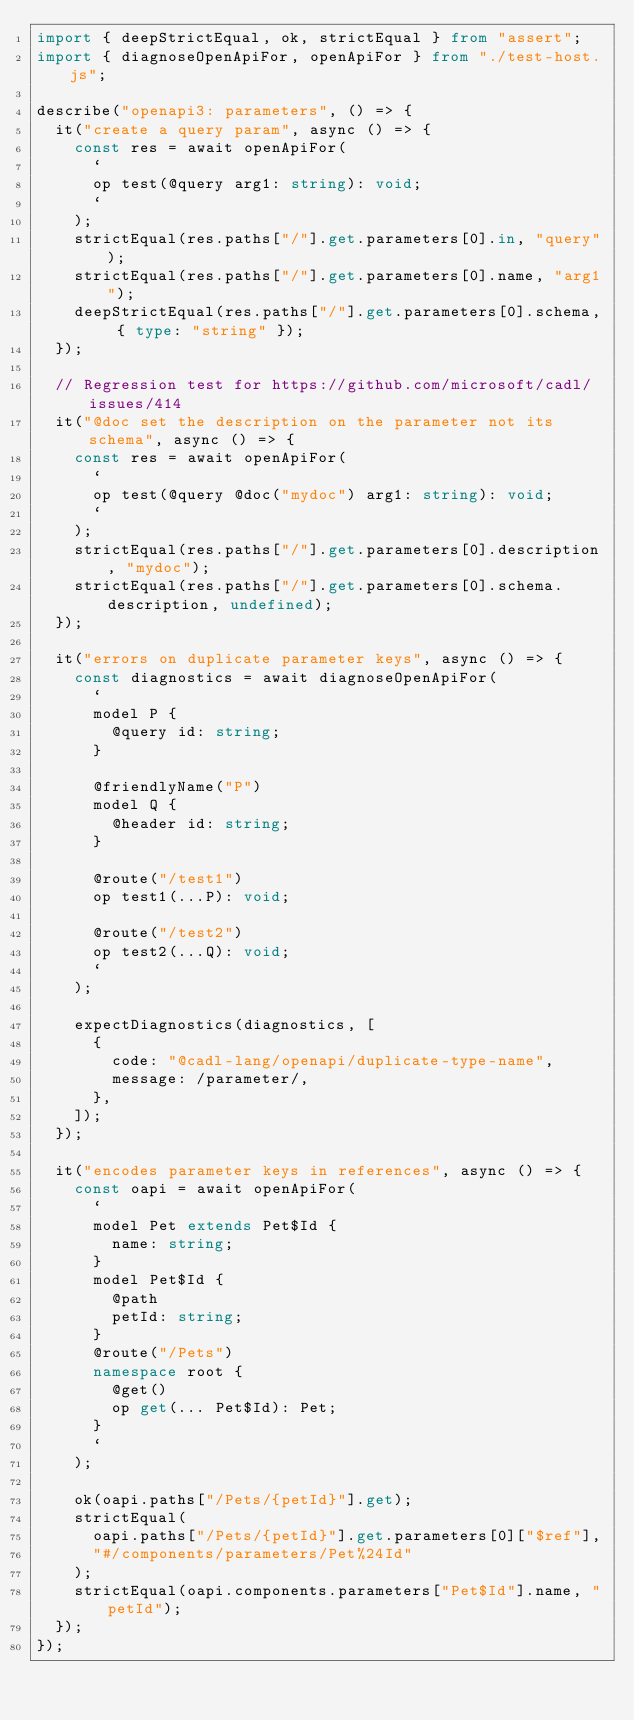<code> <loc_0><loc_0><loc_500><loc_500><_TypeScript_>import { deepStrictEqual, ok, strictEqual } from "assert";
import { diagnoseOpenApiFor, openApiFor } from "./test-host.js";

describe("openapi3: parameters", () => {
  it("create a query param", async () => {
    const res = await openApiFor(
      `
      op test(@query arg1: string): void;
      `
    );
    strictEqual(res.paths["/"].get.parameters[0].in, "query");
    strictEqual(res.paths["/"].get.parameters[0].name, "arg1");
    deepStrictEqual(res.paths["/"].get.parameters[0].schema, { type: "string" });
  });

  // Regression test for https://github.com/microsoft/cadl/issues/414
  it("@doc set the description on the parameter not its schema", async () => {
    const res = await openApiFor(
      `
      op test(@query @doc("mydoc") arg1: string): void;
      `
    );
    strictEqual(res.paths["/"].get.parameters[0].description, "mydoc");
    strictEqual(res.paths["/"].get.parameters[0].schema.description, undefined);
  });

  it("errors on duplicate parameter keys", async () => {
    const diagnostics = await diagnoseOpenApiFor(
      `
      model P {
        @query id: string;
      }

      @friendlyName("P")
      model Q {
        @header id: string;
      }

      @route("/test1")
      op test1(...P): void;

      @route("/test2")
      op test2(...Q): void;
      `
    );

    expectDiagnostics(diagnostics, [
      {
        code: "@cadl-lang/openapi/duplicate-type-name",
        message: /parameter/,
      },
    ]);
  });

  it("encodes parameter keys in references", async () => {
    const oapi = await openApiFor(
      `
      model Pet extends Pet$Id {
        name: string;
      }
      model Pet$Id {
        @path
        petId: string;
      }
      @route("/Pets")
      namespace root {
        @get()
        op get(... Pet$Id): Pet;
      }
      `
    );

    ok(oapi.paths["/Pets/{petId}"].get);
    strictEqual(
      oapi.paths["/Pets/{petId}"].get.parameters[0]["$ref"],
      "#/components/parameters/Pet%24Id"
    );
    strictEqual(oapi.components.parameters["Pet$Id"].name, "petId");
  });
});
</code> 